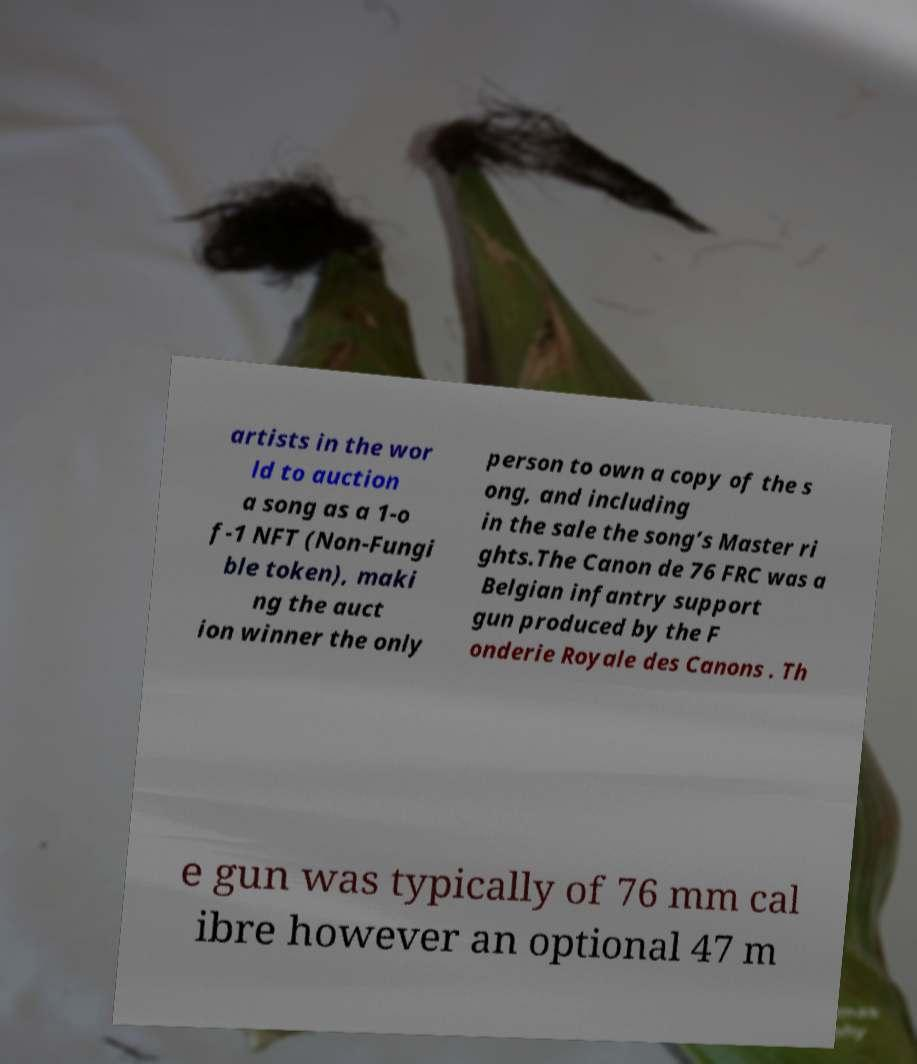Can you read and provide the text displayed in the image?This photo seems to have some interesting text. Can you extract and type it out for me? artists in the wor ld to auction a song as a 1-o f-1 NFT (Non-Fungi ble token), maki ng the auct ion winner the only person to own a copy of the s ong, and including in the sale the song’s Master ri ghts.The Canon de 76 FRC was a Belgian infantry support gun produced by the F onderie Royale des Canons . Th e gun was typically of 76 mm cal ibre however an optional 47 m 